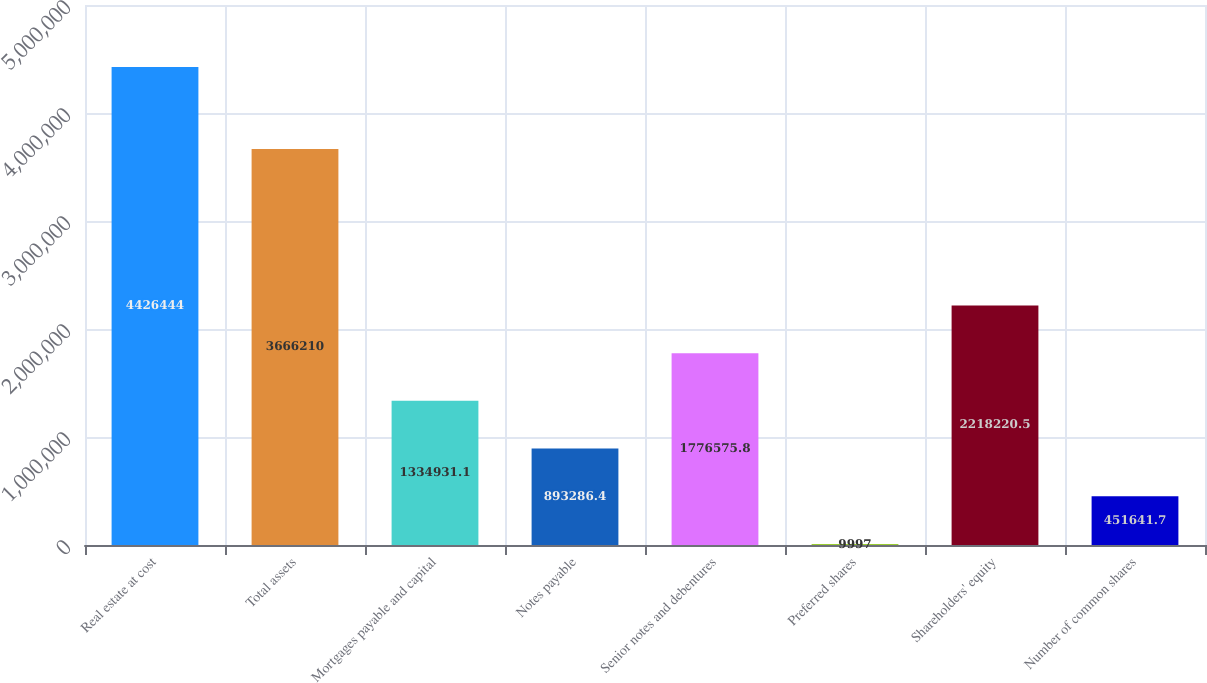Convert chart. <chart><loc_0><loc_0><loc_500><loc_500><bar_chart><fcel>Real estate at cost<fcel>Total assets<fcel>Mortgages payable and capital<fcel>Notes payable<fcel>Senior notes and debentures<fcel>Preferred shares<fcel>Shareholders' equity<fcel>Number of common shares<nl><fcel>4.42644e+06<fcel>3.66621e+06<fcel>1.33493e+06<fcel>893286<fcel>1.77658e+06<fcel>9997<fcel>2.21822e+06<fcel>451642<nl></chart> 